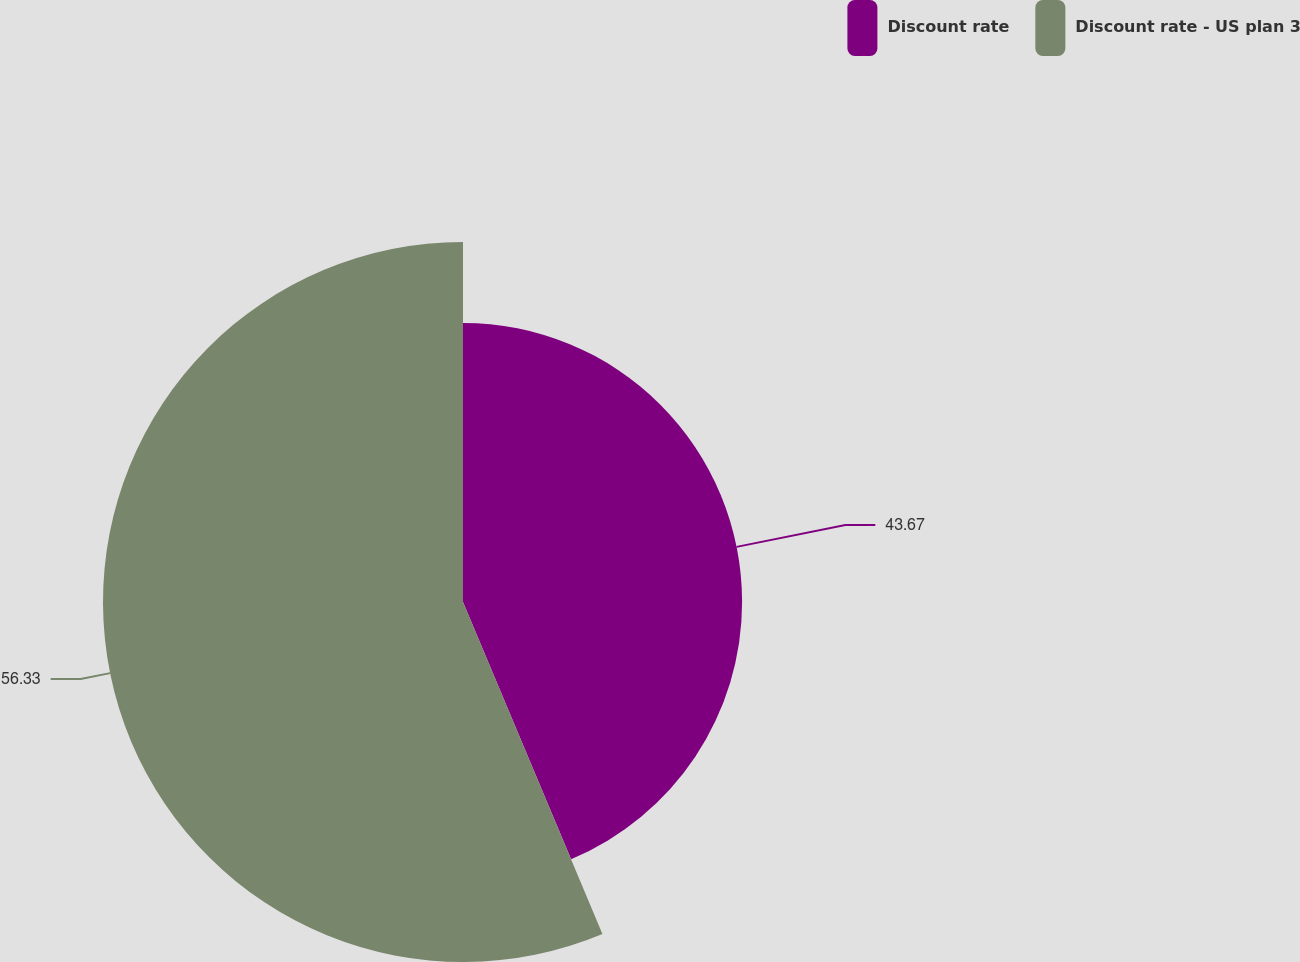<chart> <loc_0><loc_0><loc_500><loc_500><pie_chart><fcel>Discount rate<fcel>Discount rate - US plan 3<nl><fcel>43.67%<fcel>56.33%<nl></chart> 